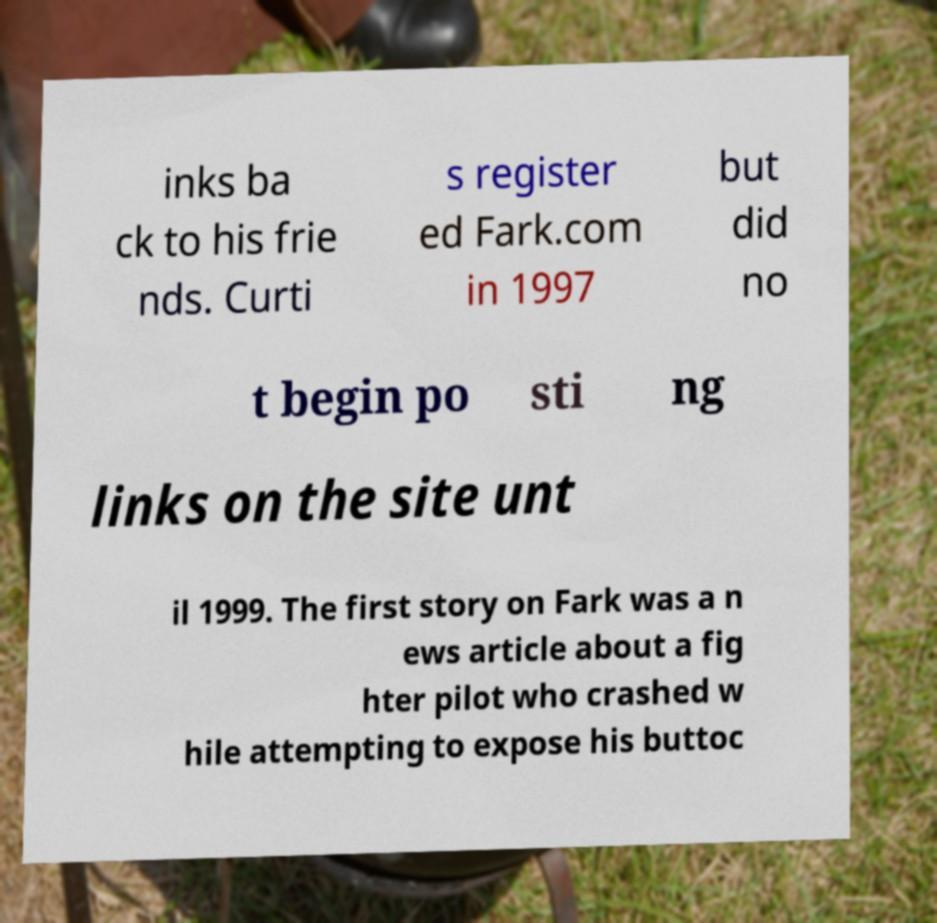What messages or text are displayed in this image? I need them in a readable, typed format. inks ba ck to his frie nds. Curti s register ed Fark.com in 1997 but did no t begin po sti ng links on the site unt il 1999. The first story on Fark was a n ews article about a fig hter pilot who crashed w hile attempting to expose his buttoc 